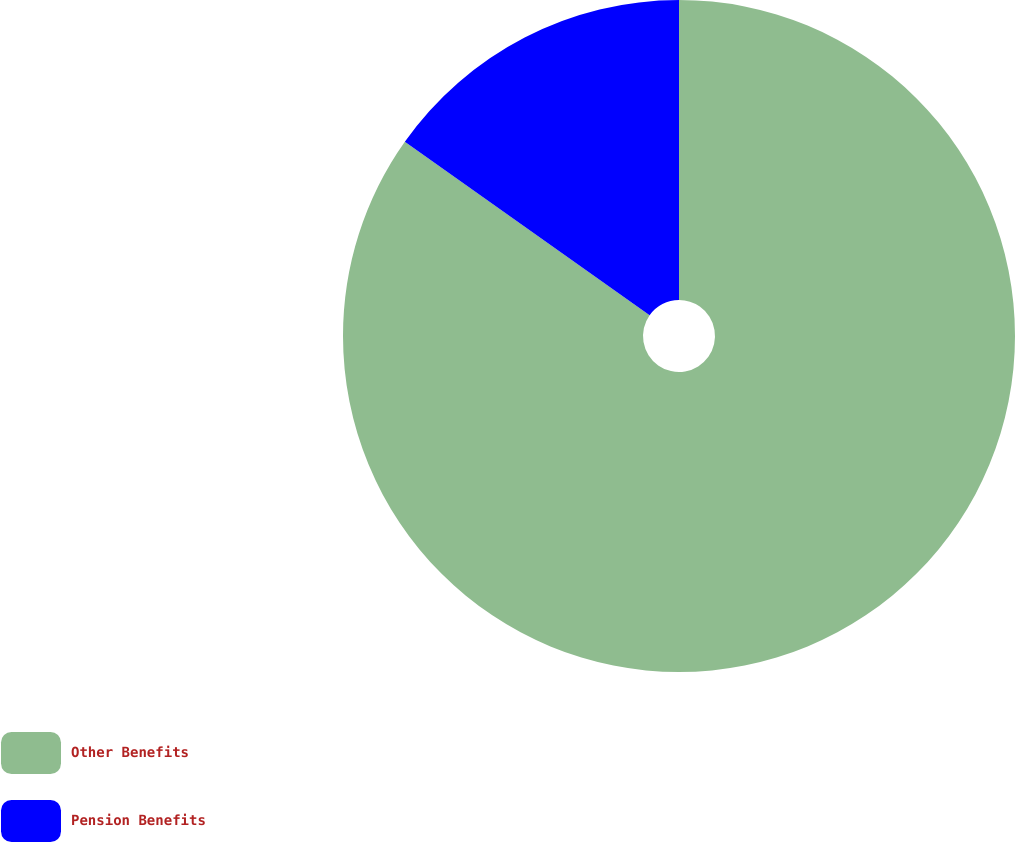Convert chart to OTSL. <chart><loc_0><loc_0><loc_500><loc_500><pie_chart><fcel>Other Benefits<fcel>Pension Benefits<nl><fcel>84.81%<fcel>15.19%<nl></chart> 